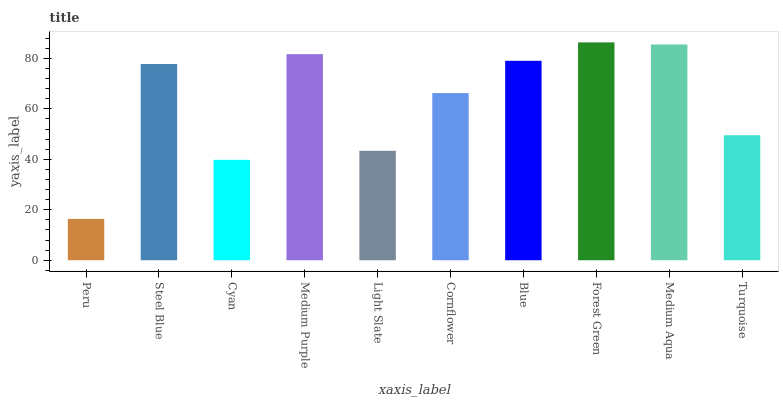Is Peru the minimum?
Answer yes or no. Yes. Is Forest Green the maximum?
Answer yes or no. Yes. Is Steel Blue the minimum?
Answer yes or no. No. Is Steel Blue the maximum?
Answer yes or no. No. Is Steel Blue greater than Peru?
Answer yes or no. Yes. Is Peru less than Steel Blue?
Answer yes or no. Yes. Is Peru greater than Steel Blue?
Answer yes or no. No. Is Steel Blue less than Peru?
Answer yes or no. No. Is Steel Blue the high median?
Answer yes or no. Yes. Is Cornflower the low median?
Answer yes or no. Yes. Is Cornflower the high median?
Answer yes or no. No. Is Medium Aqua the low median?
Answer yes or no. No. 